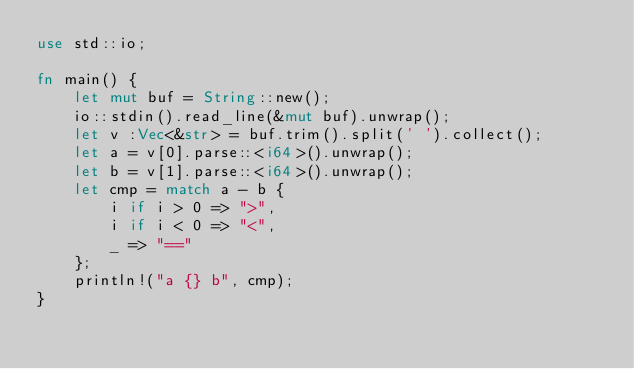Convert code to text. <code><loc_0><loc_0><loc_500><loc_500><_Rust_>use std::io; 

fn main() {
    let mut buf = String::new();
    io::stdin().read_line(&mut buf).unwrap();
    let v :Vec<&str> = buf.trim().split(' ').collect();
    let a = v[0].parse::<i64>().unwrap();
    let b = v[1].parse::<i64>().unwrap();
    let cmp = match a - b {
        i if i > 0 => ">",
        i if i < 0 => "<",
        _ => "=="
    };
    println!("a {} b", cmp);
}
</code> 